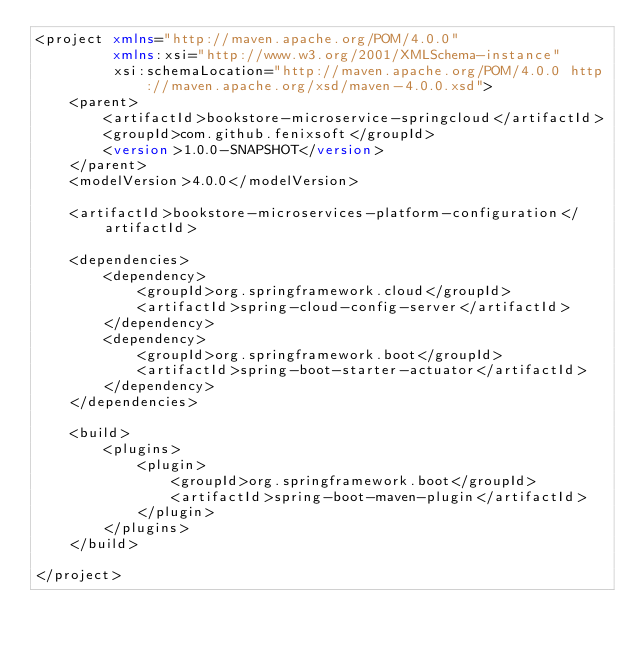Convert code to text. <code><loc_0><loc_0><loc_500><loc_500><_XML_><project xmlns="http://maven.apache.org/POM/4.0.0"
         xmlns:xsi="http://www.w3.org/2001/XMLSchema-instance"
         xsi:schemaLocation="http://maven.apache.org/POM/4.0.0 http://maven.apache.org/xsd/maven-4.0.0.xsd">
    <parent>
        <artifactId>bookstore-microservice-springcloud</artifactId>
        <groupId>com.github.fenixsoft</groupId>
        <version>1.0.0-SNAPSHOT</version>
    </parent>
    <modelVersion>4.0.0</modelVersion>

    <artifactId>bookstore-microservices-platform-configuration</artifactId>

    <dependencies>
        <dependency>
            <groupId>org.springframework.cloud</groupId>
            <artifactId>spring-cloud-config-server</artifactId>
        </dependency>
        <dependency>
            <groupId>org.springframework.boot</groupId>
            <artifactId>spring-boot-starter-actuator</artifactId>
        </dependency>
    </dependencies>

    <build>
        <plugins>
            <plugin>
                <groupId>org.springframework.boot</groupId>
                <artifactId>spring-boot-maven-plugin</artifactId>
            </plugin>
        </plugins>
    </build>

</project>
</code> 